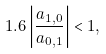Convert formula to latex. <formula><loc_0><loc_0><loc_500><loc_500>1 . 6 \left | \frac { a _ { 1 , 0 } } { a _ { 0 , 1 } } \right | < 1 ,</formula> 